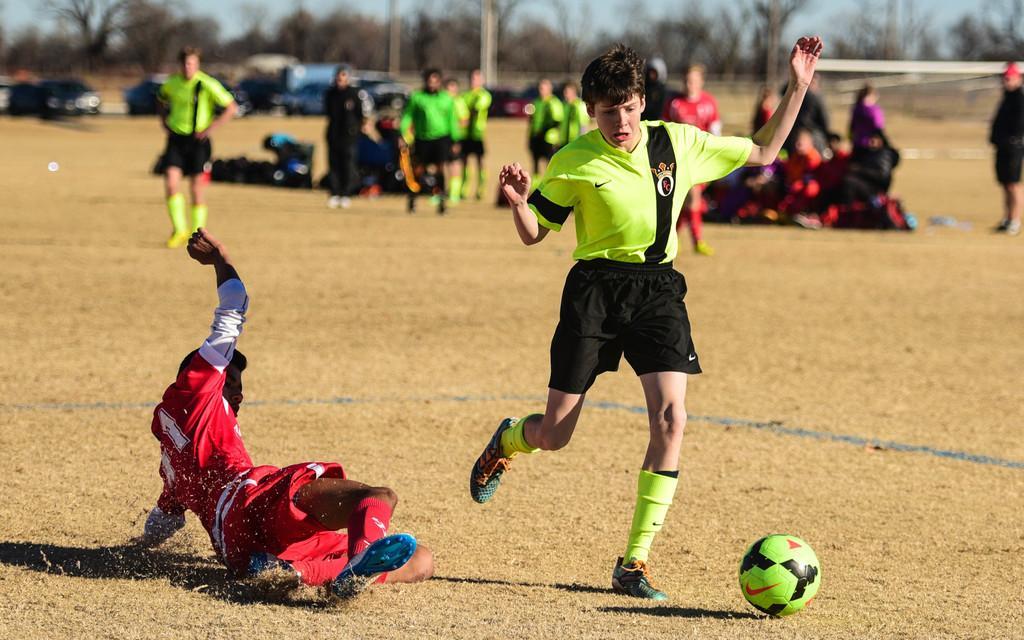Could you give a brief overview of what you see in this image? This image is taken outdoors. At the bottom of the image there is a ground with grass on it. In the middle of the image a boy is running on the ground and he is about to kick a ball. On the left side of the image a man fell on the ground. In the background a few people are standing on the ground and there are many trees and a few vehicles are parked on the ground. 